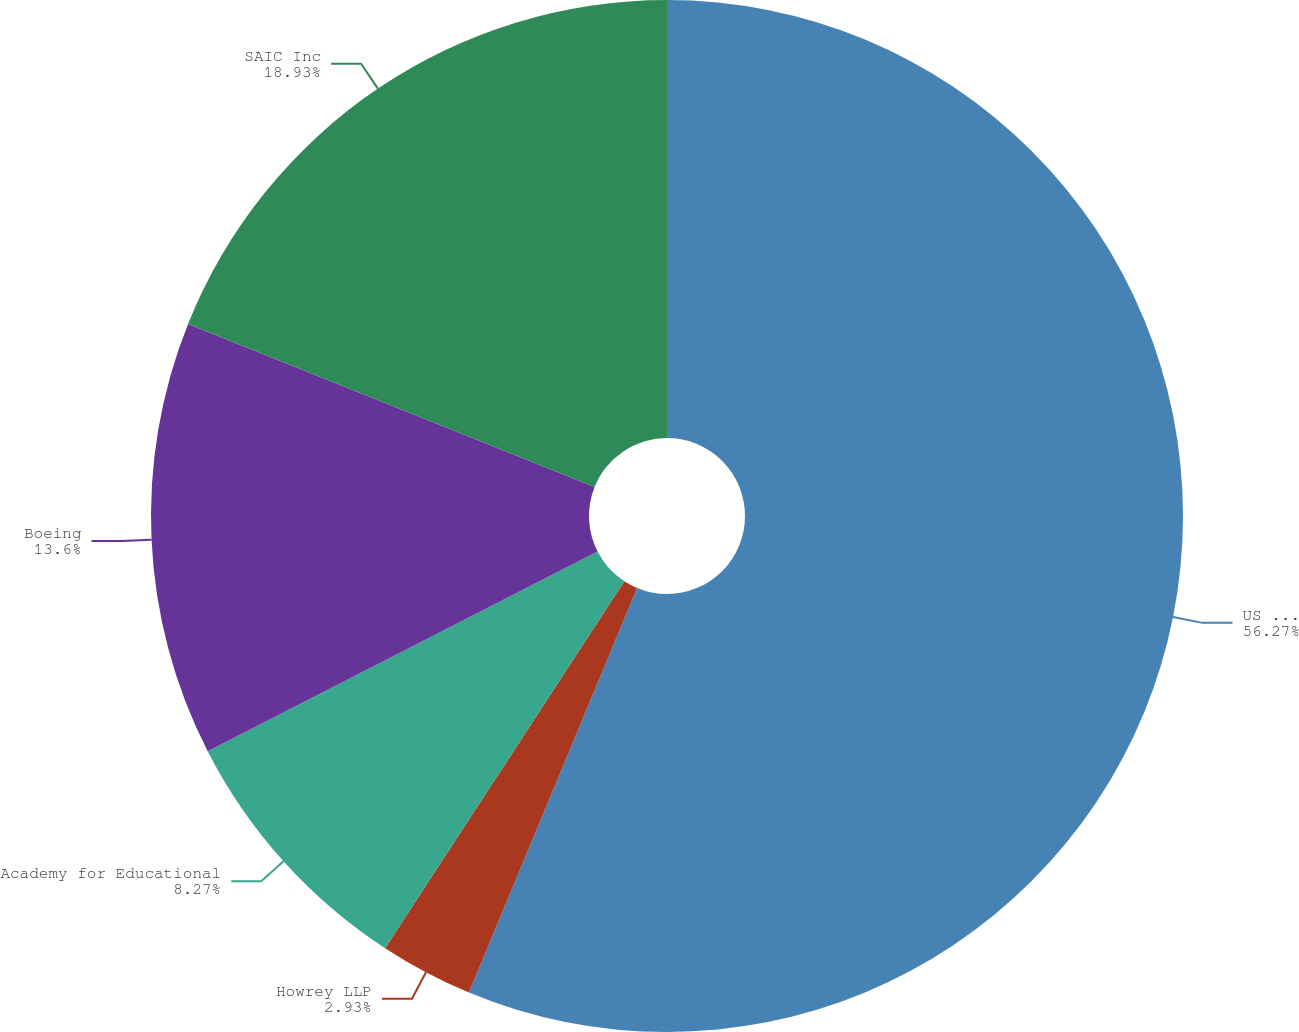Convert chart. <chart><loc_0><loc_0><loc_500><loc_500><pie_chart><fcel>US Government<fcel>Howrey LLP<fcel>Academy for Educational<fcel>Boeing<fcel>SAIC Inc<nl><fcel>56.27%<fcel>2.93%<fcel>8.27%<fcel>13.6%<fcel>18.93%<nl></chart> 